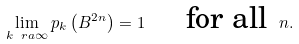Convert formula to latex. <formula><loc_0><loc_0><loc_500><loc_500>\lim _ { k \ r a \infty } p _ { k } \left ( B ^ { 2 n } \right ) = 1 \quad \, \text { for all } \, n .</formula> 